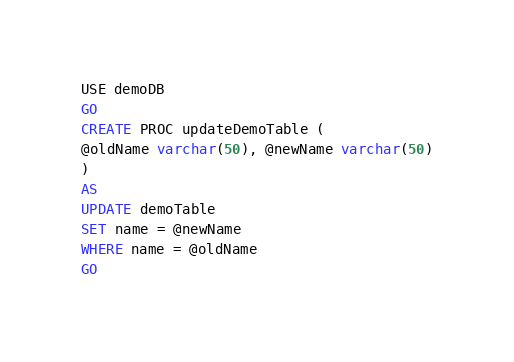<code> <loc_0><loc_0><loc_500><loc_500><_SQL_>USE demoDB
GO
CREATE PROC updateDemoTable (
@oldName varchar(50), @newName varchar(50)
)
AS
UPDATE demoTable
SET name = @newName
WHERE name = @oldName
GO
</code> 